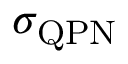Convert formula to latex. <formula><loc_0><loc_0><loc_500><loc_500>\sigma _ { Q P N }</formula> 